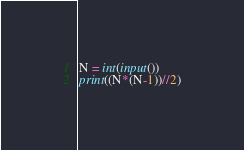Convert code to text. <code><loc_0><loc_0><loc_500><loc_500><_Python_>N = int(input())
print((N*(N-1))//2)</code> 